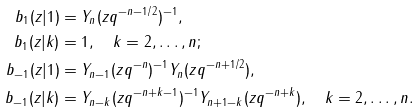Convert formula to latex. <formula><loc_0><loc_0><loc_500><loc_500>b _ { 1 } ( z | 1 ) & = Y _ { n } ( z q ^ { - n - 1 / 2 } ) ^ { - 1 } , \\ b _ { 1 } ( z | k ) & = 1 , \quad k = 2 , \dots , n ; \\ b _ { - 1 } ( z | 1 ) & = Y _ { n - 1 } ( z q ^ { - n } ) ^ { - 1 } Y _ { n } ( z q ^ { - n + 1 / 2 } ) , \\ b _ { - 1 } ( z | k ) & = Y _ { n - k } ( z q ^ { - n + k - 1 } ) ^ { - 1 } Y _ { n + 1 - k } ( z q ^ { - n + k } ) , \quad k = 2 , \dots , n .</formula> 